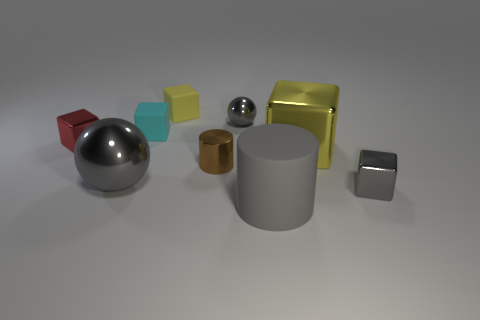Is the color of the large sphere the same as the large matte thing?
Your response must be concise. Yes. There is a big matte thing; is its color the same as the sphere that is in front of the small cyan rubber cube?
Make the answer very short. Yes. There is a tiny metal block that is right of the big gray rubber thing; does it have the same color as the tiny metal sphere?
Provide a short and direct response. Yes. There is another ball that is the same color as the big metal ball; what is it made of?
Make the answer very short. Metal. Are there any matte cylinders of the same color as the large sphere?
Your answer should be compact. Yes. The large gray object that is made of the same material as the tiny yellow thing is what shape?
Your answer should be compact. Cylinder. How big is the brown cylinder on the right side of the big gray thing that is behind the gray metallic cube?
Offer a terse response. Small. How many small things are either cyan balls or gray matte cylinders?
Your answer should be compact. 0. What number of other objects are there of the same color as the tiny ball?
Your answer should be compact. 3. There is a metal block that is on the left side of the tiny brown shiny cylinder; is it the same size as the gray sphere right of the tiny metal cylinder?
Your response must be concise. Yes. 